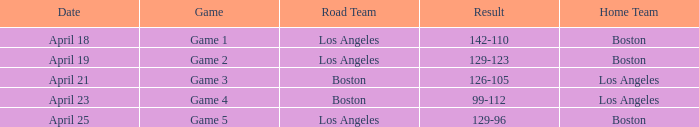WHAT IS THE RESULT OF THE GAME ON APRIL 23? 99-112. 